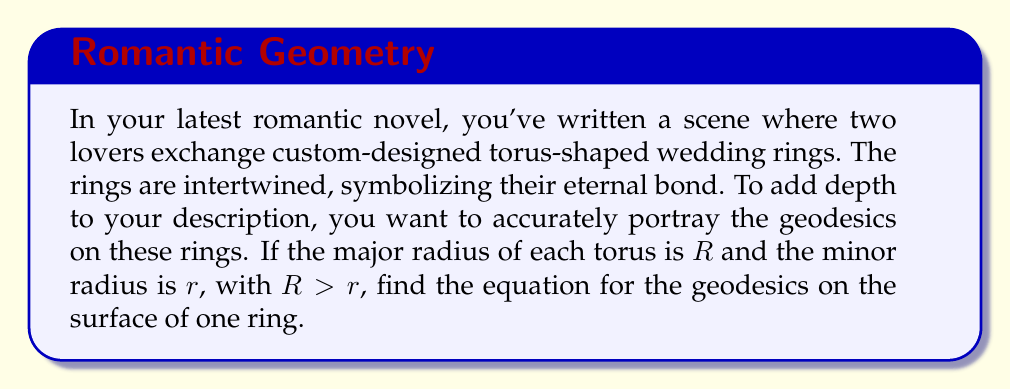Give your solution to this math problem. Let's approach this step-by-step:

1) First, we need to parameterize the torus. We can do this using two angles, $\theta$ and $\phi$:

   $$x = (R + r\cos\phi)\cos\theta$$
   $$y = (R + r\cos\phi)\sin\theta$$
   $$z = r\sin\phi$$

   Where $0 \leq \theta < 2\pi$ and $0 \leq \phi < 2\pi$.

2) The geodesic equation on a surface is given by:

   $$\frac{d^2x^i}{ds^2} + \Gamma^i_{jk}\frac{dx^j}{ds}\frac{dx^k}{ds} = 0$$

   Where $\Gamma^i_{jk}$ are the Christoffel symbols and $s$ is the arc length.

3) For a torus, this equation can be simplified to:

   $$\frac{d^2\theta}{ds^2} - \frac{r\sin\phi}{R + r\cos\phi}\frac{d\theta}{ds}\frac{d\phi}{ds} = 0$$
   $$\frac{d^2\phi}{ds^2} + (R + r\cos\phi)\cos\phi\left(\frac{d\theta}{ds}\right)^2 = 0$$

4) These equations can be combined into a single equation:

   $$\frac{d\phi}{d\theta} = \pm \frac{\sqrt{c^2(R + r\cos\phi)^2 - (R + r\cos\phi)^4}}{r(R + r\cos\phi)}$$

   Where $c$ is a constant of integration.

5) This equation describes the geodesics on the surface of the torus. The $\pm$ sign indicates that the geodesics can wind in either direction around the torus.

6) The constant $c$ determines the nature of the geodesic:
   - If $c < R - r$, the geodesic doesn't wind around the hole of the torus.
   - If $R - r < c < R + r$, the geodesic winds around both the hole and the body of the torus.
   - If $c > R + r$, the geodesic winds only around the hole of the torus.
Answer: $$\frac{d\phi}{d\theta} = \pm \frac{\sqrt{c^2(R + r\cos\phi)^2 - (R + r\cos\phi)^4}}{r(R + r\cos\phi)}$$ 